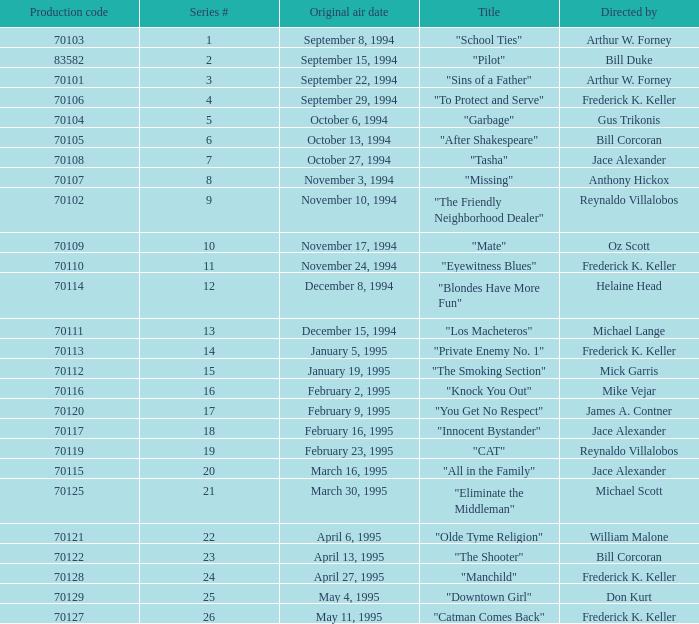What was the lowest production code value in series #10? 70109.0. 